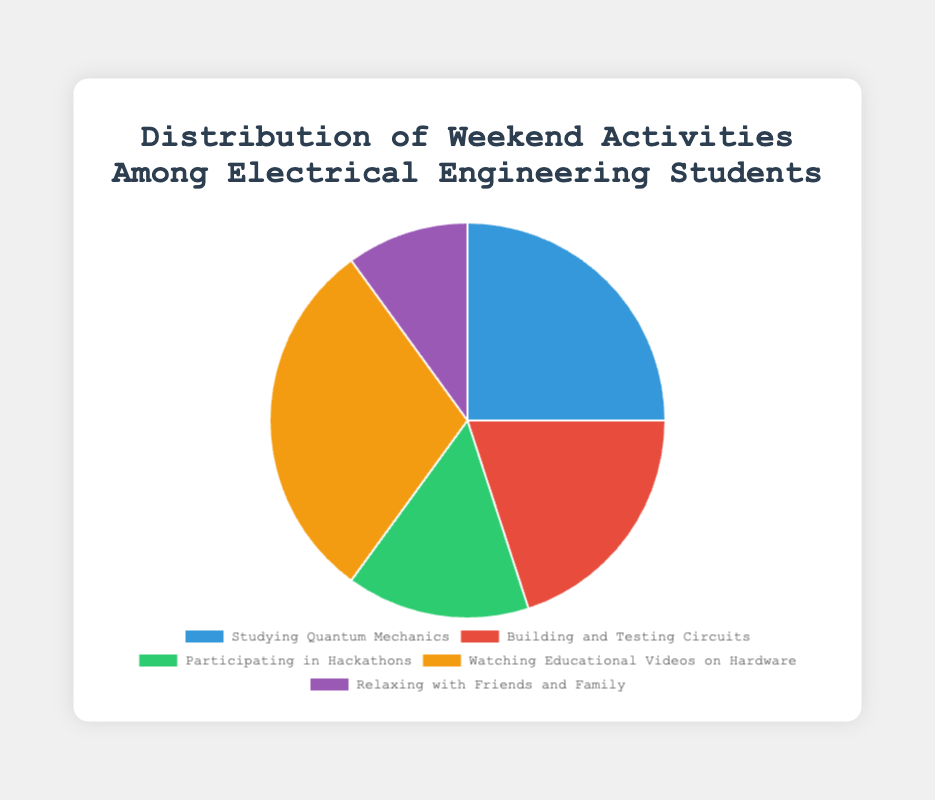Which activity do the majority of electrical engineering students spend their weekend on? The activity with the largest percentage in the chart is "Watching Educational Videos on Hardware" at 30%.
Answer: Watching Educational Videos on Hardware Which activity has the lowest percentage of participation among students? The activity with the lowest percentage in the chart is "Relaxing with Friends and Family" at 10%.
Answer: Relaxing with Friends and Family What is the combined percentage of students who spend their weekends Studying Quantum Mechanics and Building and Testing Circuits? Studying Quantum Mechanics is 25% and Building and Testing Circuits is 20%; adding them together gives 25% + 20% = 45%.
Answer: 45% Is the percentage of students participating in Hackathons greater than those who are relaxing with friends and family? If so, by how much? Participating in Hackathons is 15% and Relaxing with Friends and Family is 10%. The difference is 15% - 10% = 5%.
Answer: Yes, by 5% Which two activities together make up over half of the student's weekend activities? Watching Educational Videos on Hardware is 30%, and Studying Quantum Mechanics is 25%. Together, 30% + 25% = 55%, which is over half of the student's weekend activities.
Answer: Watching Educational Videos on Hardware and Studying Quantum Mechanics What is the average percentage of the five activities? The percentages are 25, 20, 15, 30, and 10. Adding them gives 100. Dividing by 5 gives 100 / 5 = 20.
Answer: 20 Compare the percentage of students who are Building and Testing Circuits to those who are Participating in Hackathons. Building and Testing Circuits is 20% while Participating in Hackathons is 15%. Building and Testing Circuits has a higher percentage.
Answer: Building and Testing Circuits has a higher percentage What is the difference in percentage between the activity with the highest participation and the activity with the lowest participation? The highest participation is "Watching Educational Videos on Hardware" at 30% and the lowest is "Relaxing with Friends and Family" at 10%. The difference is 30% - 10% = 20%.
Answer: 20% Which activity is represented by the green slice in the pie chart? By referring to the visual attributes, the green slice corresponds to "Participating in Hackathons".
Answer: Participating in Hackathons 